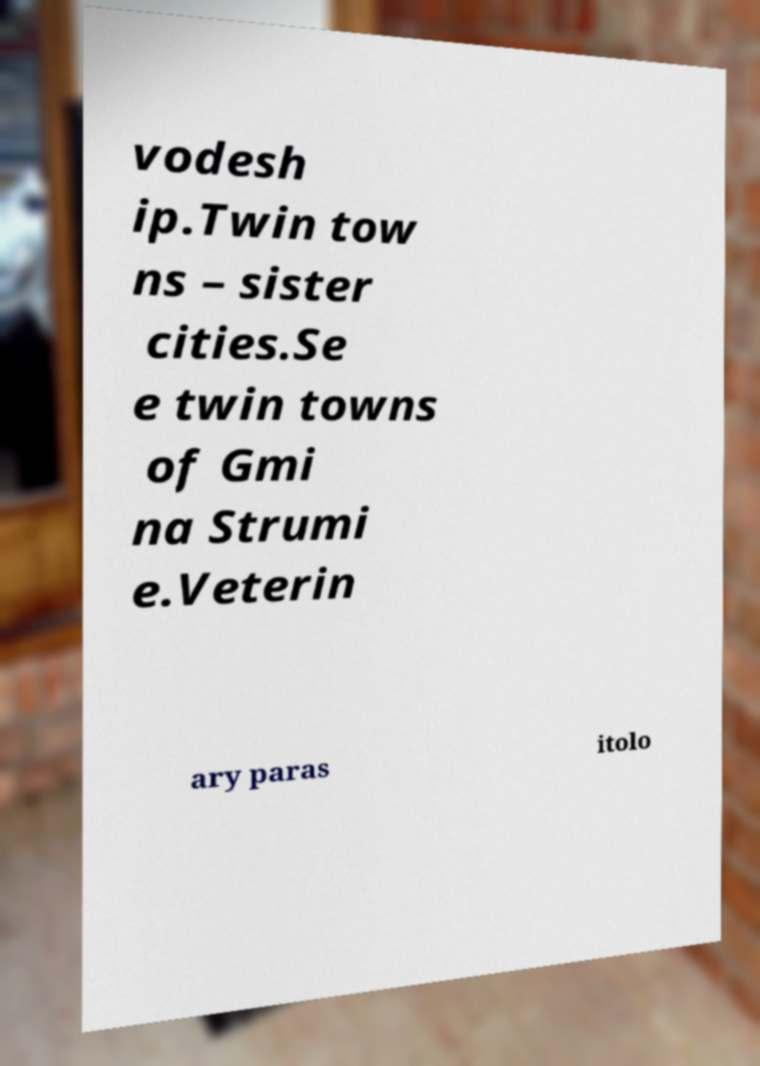I need the written content from this picture converted into text. Can you do that? vodesh ip.Twin tow ns – sister cities.Se e twin towns of Gmi na Strumi e.Veterin ary paras itolo 